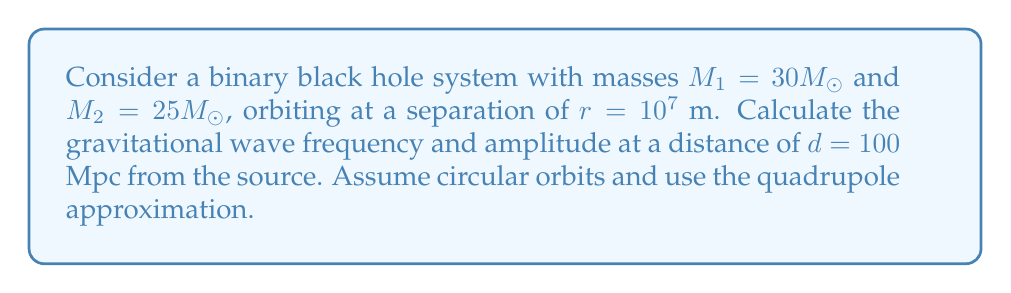Show me your answer to this math problem. 1. Calculate the total mass of the system:
   $M = M_1 + M_2 = 30M_{\odot} + 25M_{\odot} = 55M_{\odot}$

2. Calculate the reduced mass:
   $\mu = \frac{M_1M_2}{M} = \frac{30M_{\odot} \cdot 25M_{\odot}}{55M_{\odot}} \approx 13.64M_{\odot}$

3. Calculate the orbital frequency using Kepler's third law:
   $f_{\text{orb}} = \frac{1}{2\pi}\sqrt{\frac{GM}{r^3}}$
   
   $f_{\text{orb}} = \frac{1}{2\pi}\sqrt{\frac{6.67 \times 10^{-11} \cdot 55 \cdot 1.99 \times 10^{30}}{(10^7)^3}} \approx 0.0176$ Hz

4. The gravitational wave frequency is twice the orbital frequency:
   $f_{\text{GW}} = 2f_{\text{orb}} \approx 0.0352$ Hz

5. Calculate the gravitational wave amplitude using the quadrupole formula:
   $h = \frac{4G^{5/3}}{c^4}\frac{(M_1M_2)^{5/3}}{r d}(\pi f_{\text{GW}})^{2/3}$
   
   $h = \frac{4(6.67 \times 10^{-11})^{5/3}}{(3 \times 10^8)^4}\frac{(30 \cdot 25)^{5/3}(1.99 \times 10^{30})^{5/3}}{10^7 \cdot 100 \cdot 3.086 \times 10^{22}}(\pi \cdot 0.0352)^{2/3}$
   
   $h \approx 1.24 \times 10^{-21}$
Answer: $f_{\text{GW}} \approx 0.0352$ Hz, $h \approx 1.24 \times 10^{-21}$ 